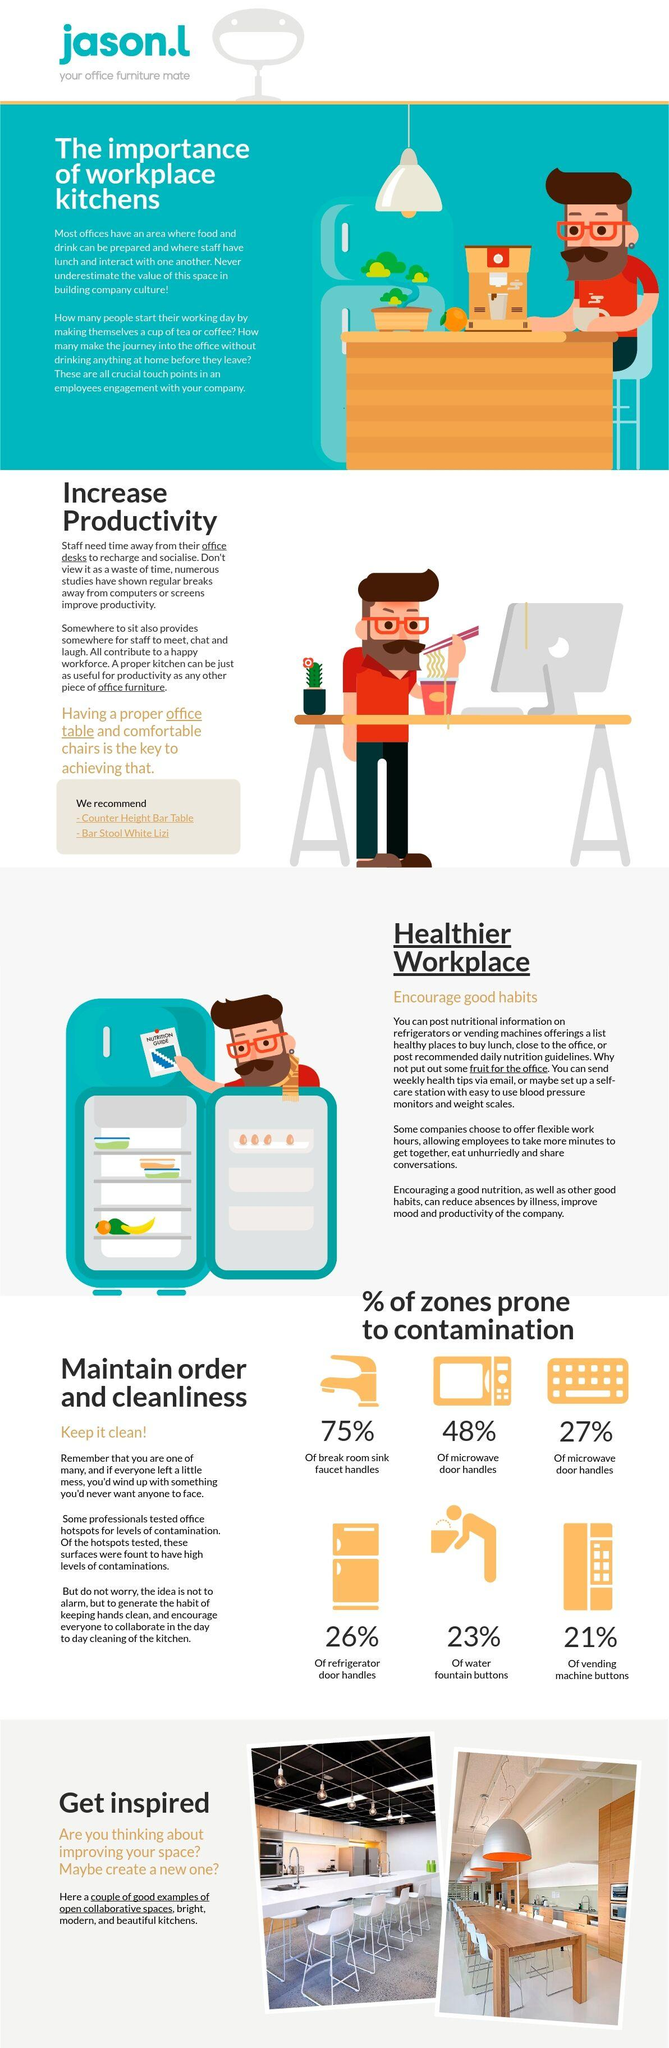List a handful of essential elements in this visual. A study has found that 75% of breakroom sink faucet handles are prone to contamination. The post placed on the refrigerator contains a nutrition guide. There are four eggs in the refrigerator. According to a study, approximately 21% of vending machine buttons are prone to contamination. There are six contamination-prone zones depicted in this image. 